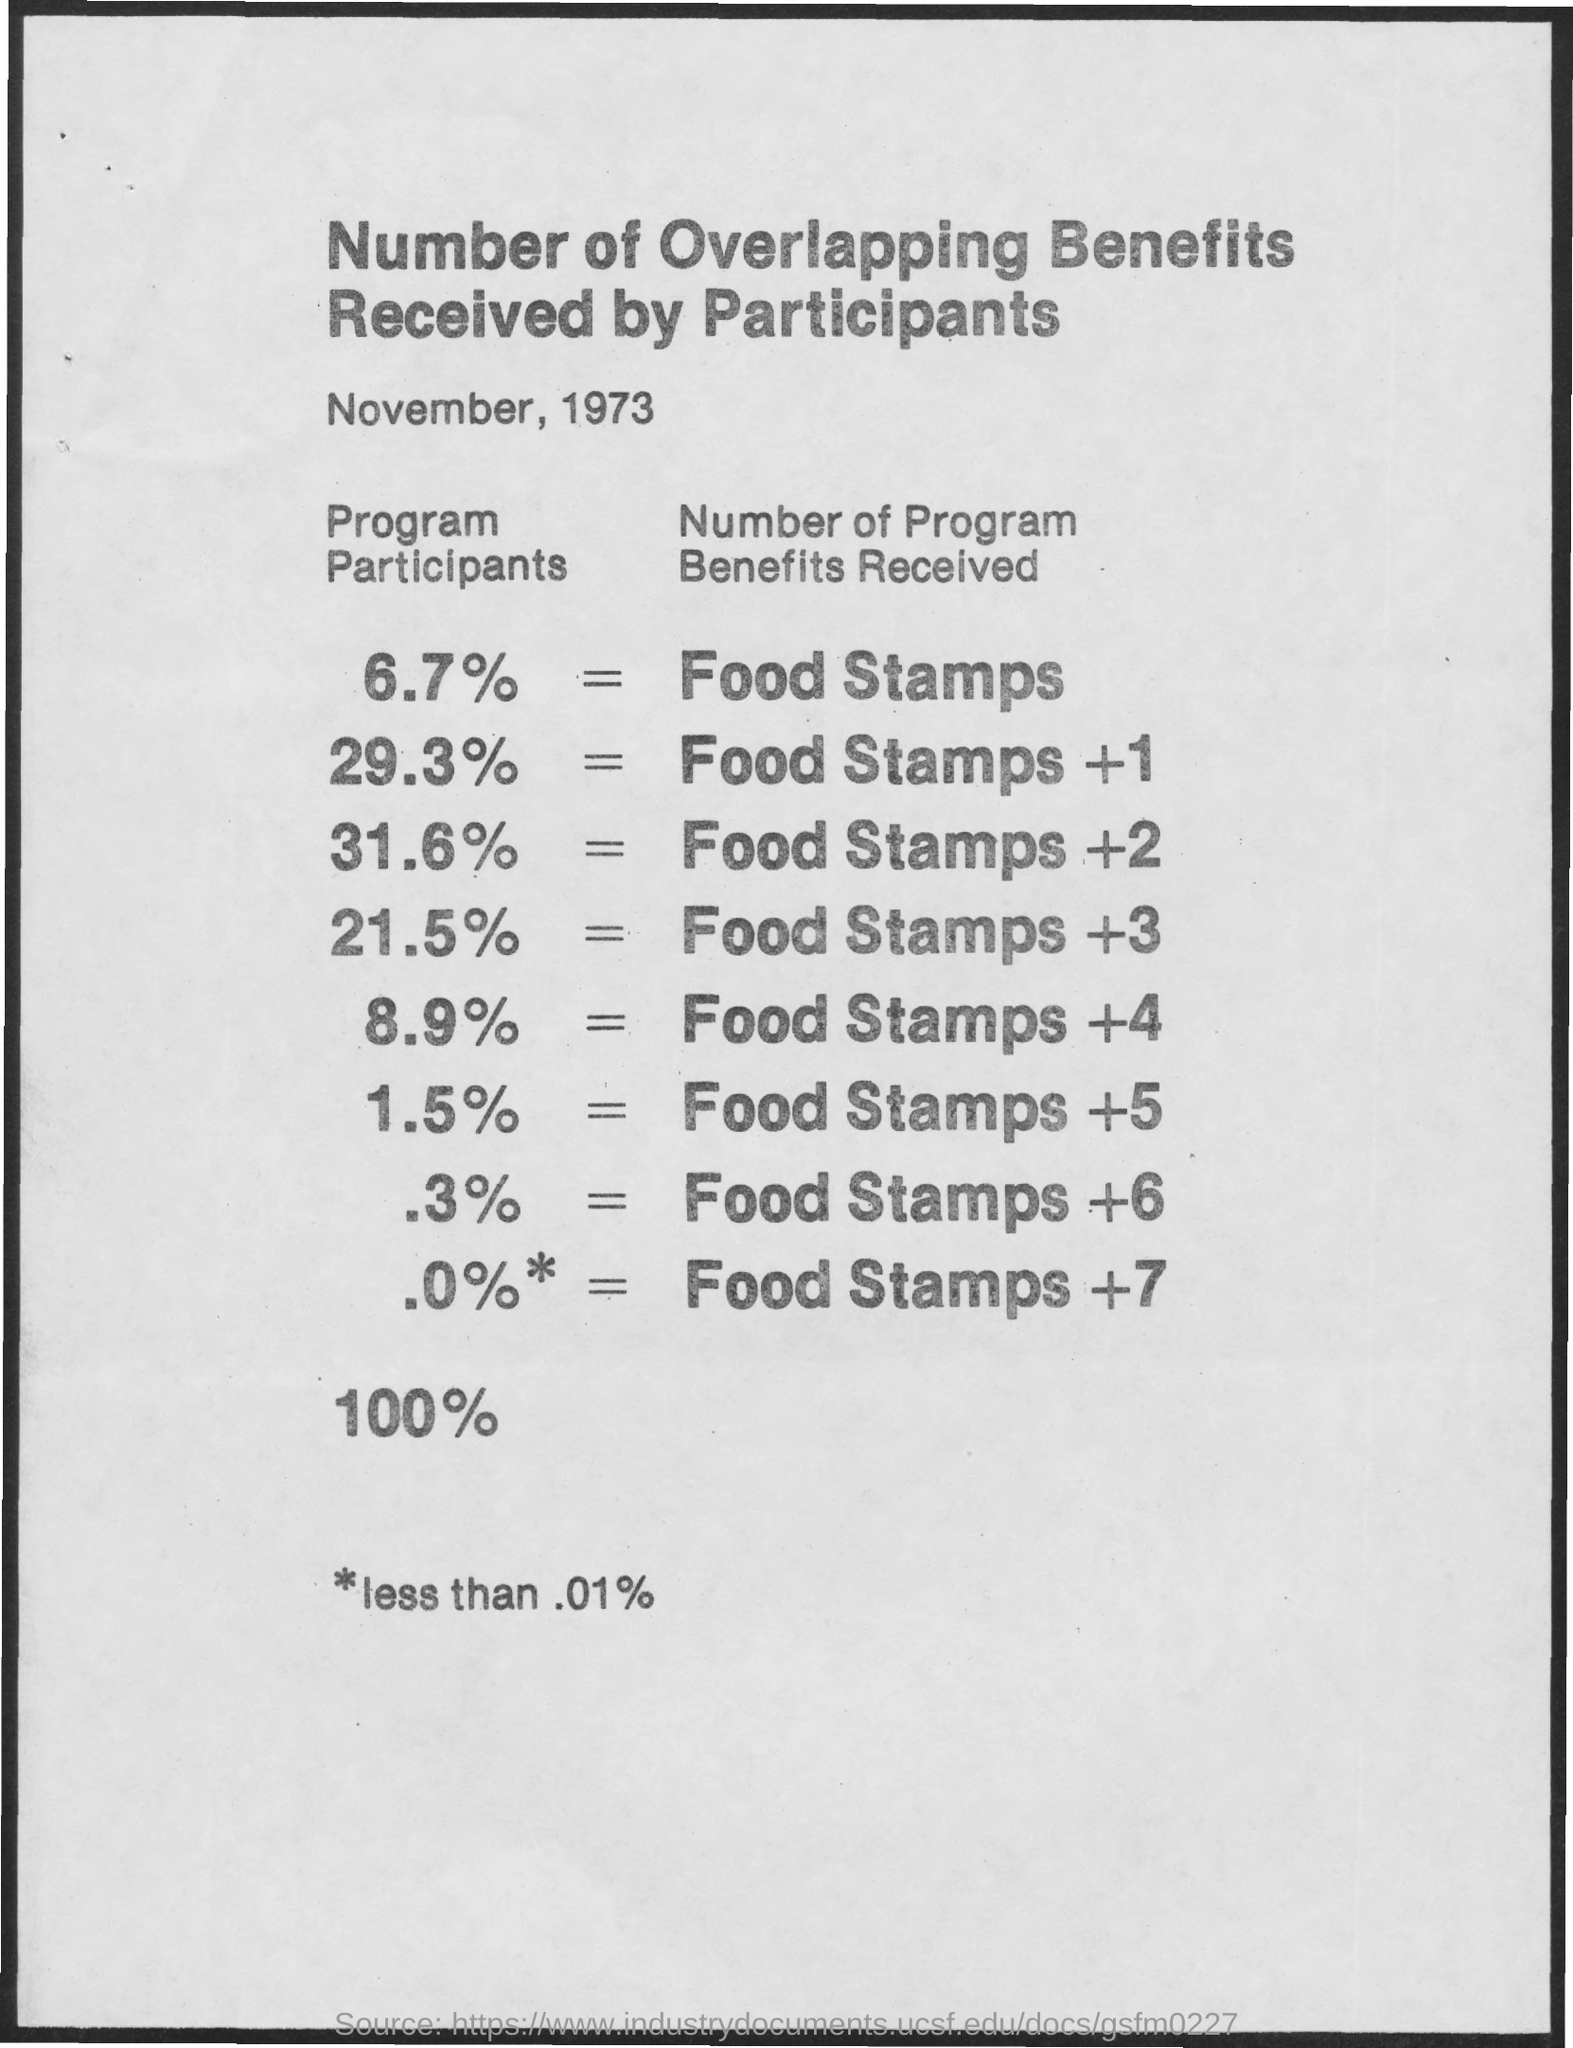What is the document title?
Offer a terse response. Number of overlapping benefits received by participants. What percentage of program participants received Food stamps + 2?
Give a very brief answer. 31.6%. When is the document dated?
Offer a very short reply. November, 1973. 